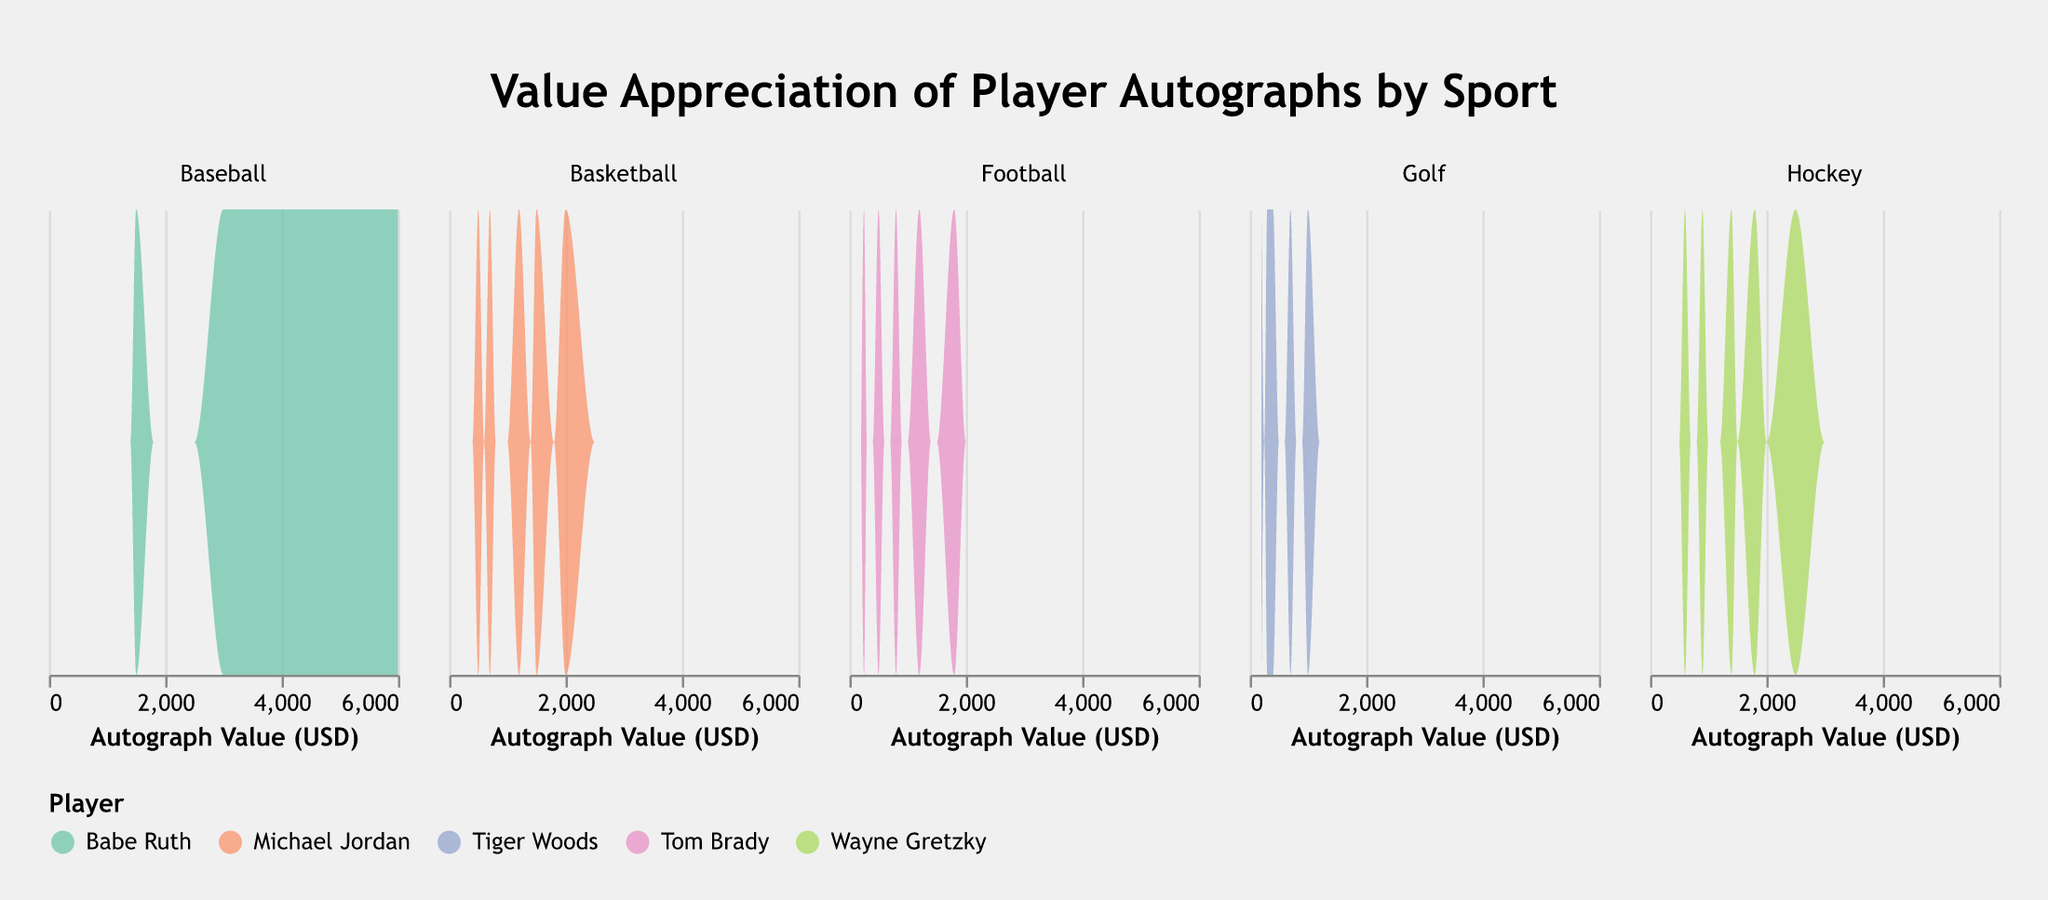What is the title of the chart? The title is usually prominently displayed at the top of the chart. For this chart, it is "Value Appreciation of Player Autographs by Sport".
Answer: Value Appreciation of Player Autographs by Sport How is the data for different players differentiated in the chart? The chart uses different colors for each player as displayed in the legend. The colors help distinguish between the density plots for different players across sports.
Answer: Different colors What information is plotted on the x-axis? The x-axis of the chart represents the "Autograph Value (USD)" which is the monetary value of the autographs. It is labeled appropriately.
Answer: Autograph Value (USD) Which player has the highest autograph value in the Baseball category? By examining the density plot under the Baseball category, we observe that Babe Ruth’s autograph values reach the highest peaks, indicating his autograph values are the highest in this category.
Answer: Babe Ruth How does the autograph value of Michael Jordan change from 2000 to 2020? Looking at the density plot for Michael Jordan under Basketball, we can see the values increase consistently over the years, with the peaks moving from lower values in 2000 (around $500) to higher values in 2020 (around $2000).
Answer: It increases Which sport shows the greatest range of autograph values? By comparing the width of the distribution in each subplot, we can observe that Baseball spans a wider range of values, from $1500 to $6000, indicating the greatest range.
Answer: Baseball Between Wayne Gretzky and Tom Brady, whose autograph value appreciated more from 2000 to 2020? Wayne Gretzky’s autograph value increased from $600 to $2500, showing an appreciation of $1900. Tom Brady’s autograph value increased from $250 to $1800, showing an appreciation of $1550. Therefore, Wayne Gretzky's autograph appreciated more.
Answer: Wayne Gretzky Which sport has the least variation in autograph values? The Golf category shows the narrowest density plot, meaning the values for Tiger Woods are closely packed and do not vary much compared to other sports.
Answer: Golf 